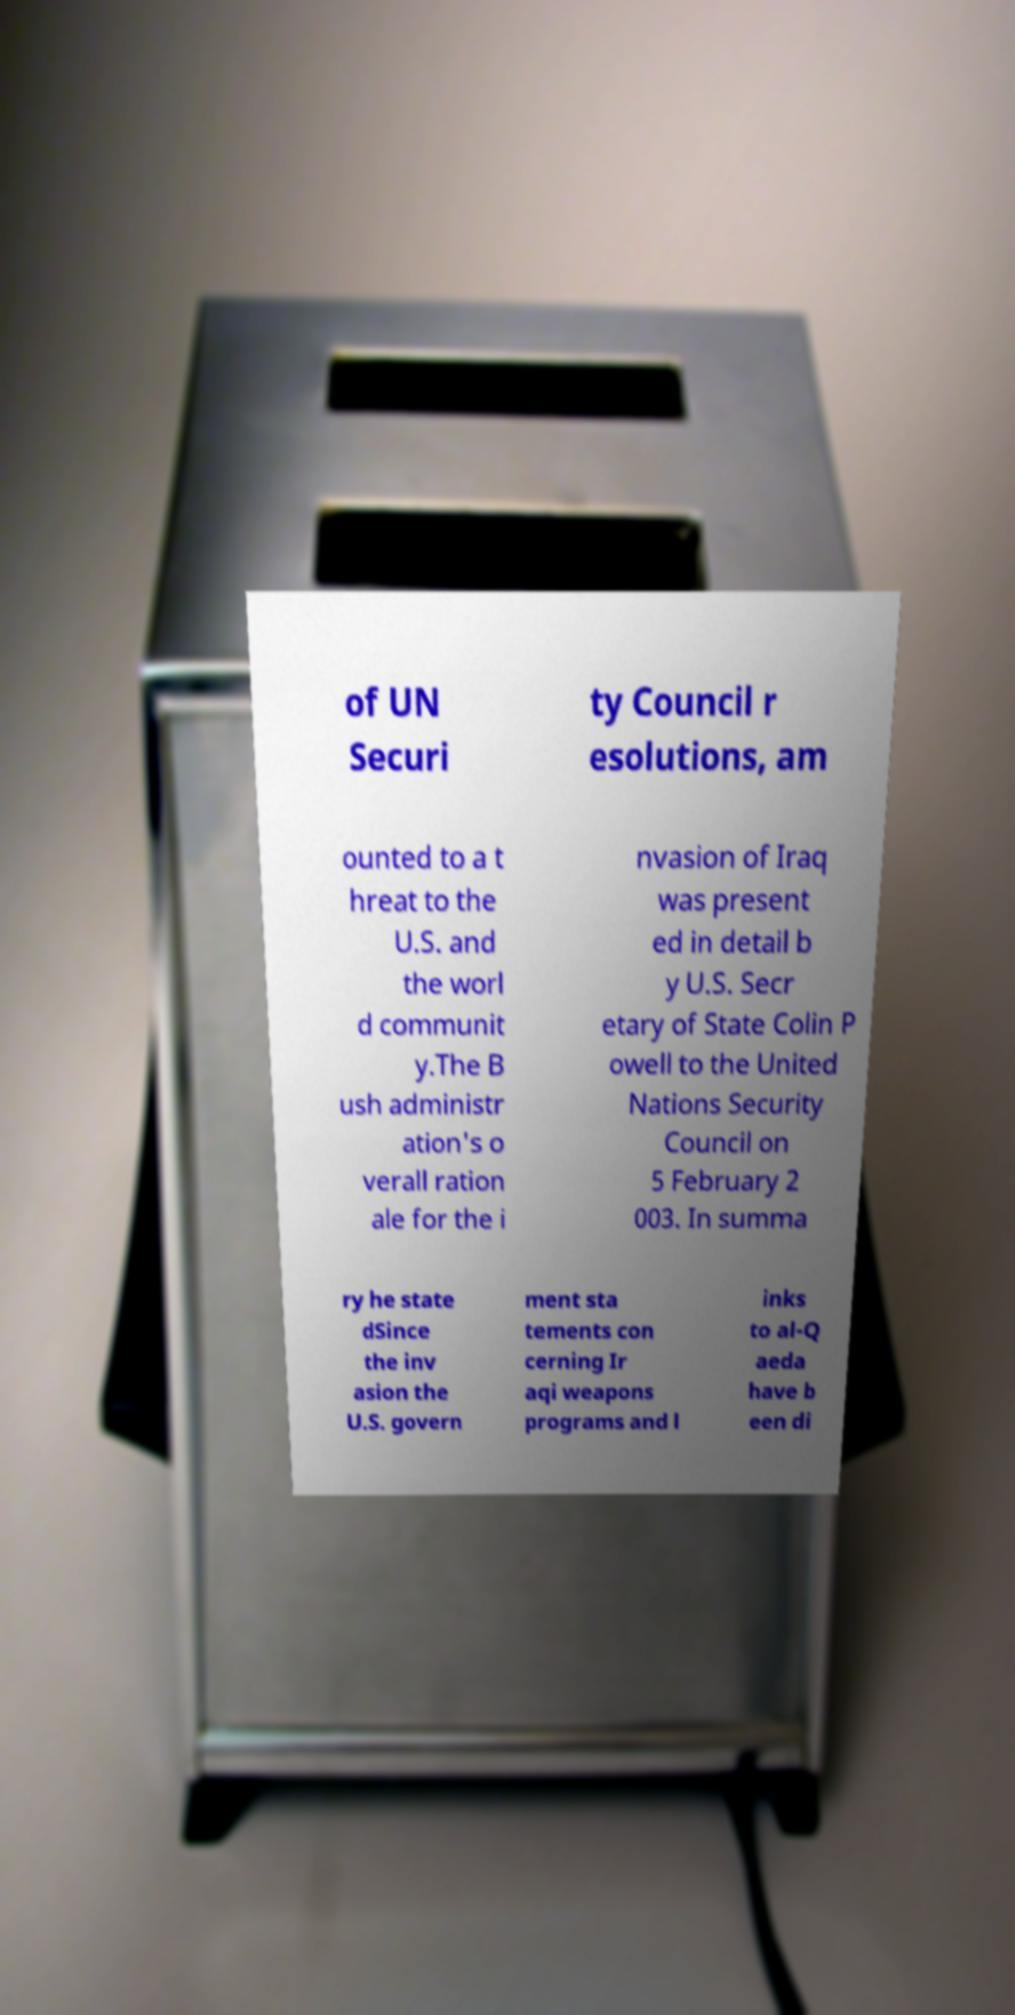Could you extract and type out the text from this image? of UN Securi ty Council r esolutions, am ounted to a t hreat to the U.S. and the worl d communit y.The B ush administr ation's o verall ration ale for the i nvasion of Iraq was present ed in detail b y U.S. Secr etary of State Colin P owell to the United Nations Security Council on 5 February 2 003. In summa ry he state dSince the inv asion the U.S. govern ment sta tements con cerning Ir aqi weapons programs and l inks to al-Q aeda have b een di 